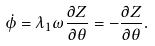Convert formula to latex. <formula><loc_0><loc_0><loc_500><loc_500>\dot { \phi } = \lambda _ { 1 } \omega \frac { \partial Z } { \partial \theta } = - \frac { \partial Z } { \partial \theta } .</formula> 